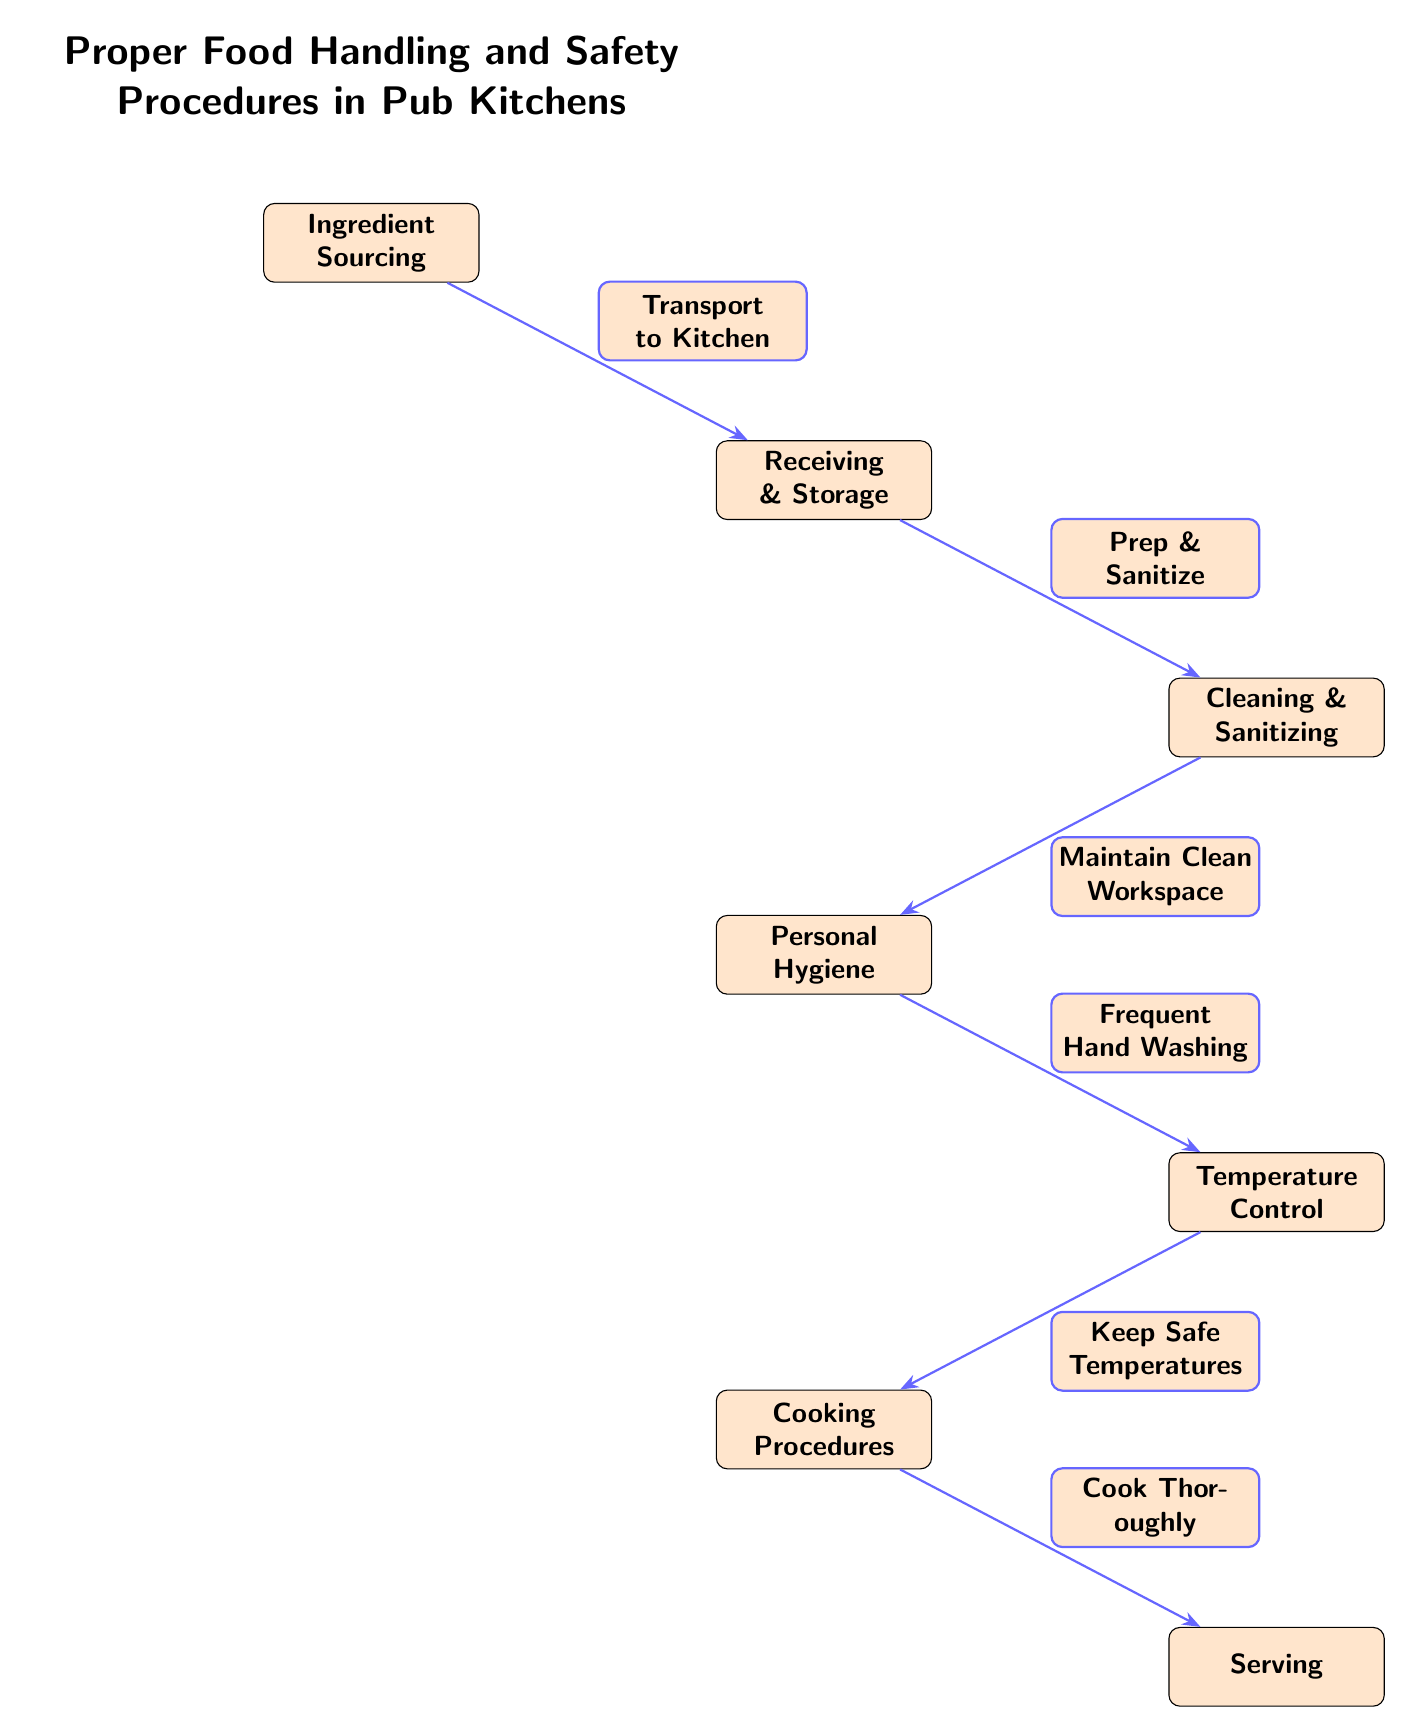What is the first step in the food handling process? The first step, represented by the first node in the diagram, is "Ingredient Sourcing." This is the starting point of the process that sets the stage for all subsequent steps.
Answer: Ingredient Sourcing How many main processes are shown in the diagram? The diagram contains a total of six main processes represented by nodes: Ingredient Sourcing, Receiving & Storage, Cleaning & Sanitizing, Personal Hygiene, Temperature Control, Cooking Procedures, and Serving. Counting these nodes provides the answer.
Answer: Six What follows after Cleaning & Sanitizing? According to the diagram, the next step that follows Cleaning & Sanitizing is Personal Hygiene, as indicated by the directed edge between these two nodes.
Answer: Personal Hygiene What is the relationship between Temperature Control and Cooking Procedures? The diagram shows a direct flow from Temperature Control to Cooking Procedures, indicating that maintaining safe temperatures is a prerequisite for cooking thoroughly. This relationship emphasizes the importance of properly controlling temperatures before cooking.
Answer: Keep Safe Temperatures What action is associated with Personal Hygiene? The edge connecting Personal Hygiene to Temperature Control indicates that "Frequent Hand Washing" is the action associated with maintaining personal hygiene in the context of food safety procedures.
Answer: Frequent Hand Washing How does one transition from Receiving & Storage to Cleaning & Sanitizing? The connection between these two nodes is made through the action denoted by the edge label "Prep & Sanitize," indicating that preparation and sanitizing steps occur after receiving and storing ingredients.
Answer: Prep & Sanitize What is the last step in the food handling process? The final step in the process, as indicated by the last node in the diagram, is "Serving." This step completes the food handling process and involves presenting the prepared food to customers.
Answer: Serving What is the main focus of the diagram? The main focus of the diagram is the flow of Proper Food Handling and Safety Procedures in Pub Kitchens, demonstrating the sequence of actions required to ensure safety and quality in food preparation.
Answer: Proper Food Handling and Safety Procedures in Pub Kitchens What needs to be maintained before cooking? The diagram emphasizes the importance of maintaining "Safe Temperatures" as a critical step that must be followed before cooking the food thoroughly. This ensures the food is safe for consumption.
Answer: Safe Temperatures 